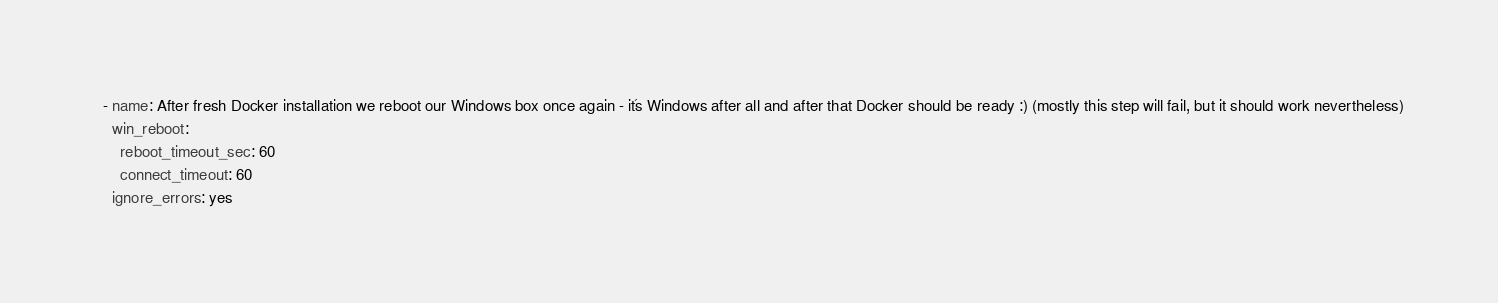Convert code to text. <code><loc_0><loc_0><loc_500><loc_500><_YAML_>  - name: After fresh Docker installation we reboot our Windows box once again - it´s Windows after all and after that Docker should be ready :) (mostly this step will fail, but it should work nevertheless)
    win_reboot:
      reboot_timeout_sec: 60
      connect_timeout: 60
    ignore_errors: yes</code> 